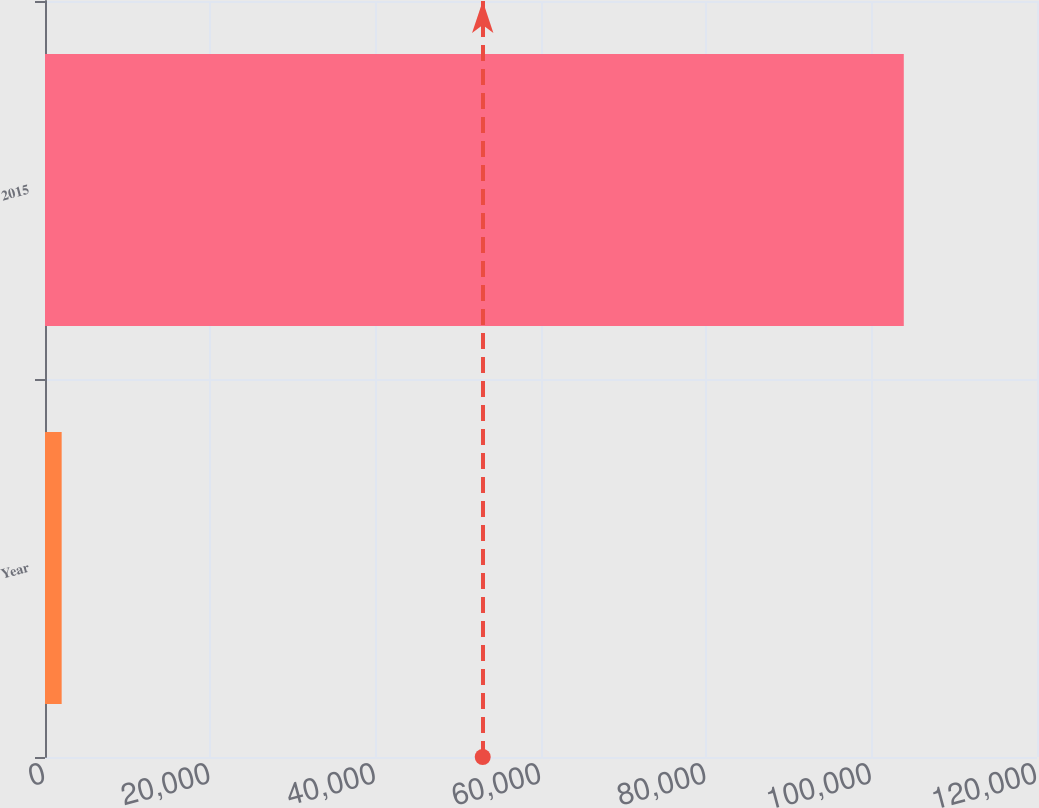<chart> <loc_0><loc_0><loc_500><loc_500><bar_chart><fcel>Year<fcel>2015<nl><fcel>2016<fcel>103885<nl></chart> 